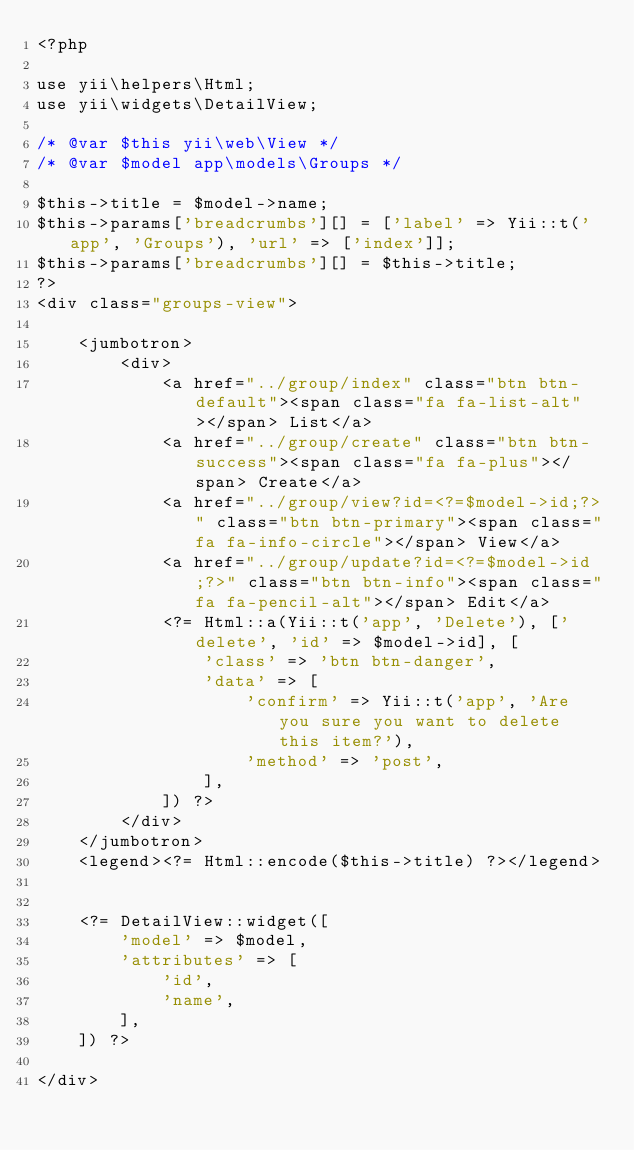<code> <loc_0><loc_0><loc_500><loc_500><_PHP_><?php

use yii\helpers\Html;
use yii\widgets\DetailView;

/* @var $this yii\web\View */
/* @var $model app\models\Groups */

$this->title = $model->name;
$this->params['breadcrumbs'][] = ['label' => Yii::t('app', 'Groups'), 'url' => ['index']];
$this->params['breadcrumbs'][] = $this->title;
?>
<div class="groups-view">

    <jumbotron>
        <div>
            <a href="../group/index" class="btn btn-default"><span class="fa fa-list-alt"></span> List</a>
            <a href="../group/create" class="btn btn-success"><span class="fa fa-plus"></span> Create</a>
            <a href="../group/view?id=<?=$model->id;?>" class="btn btn-primary"><span class="fa fa-info-circle"></span> View</a>
            <a href="../group/update?id=<?=$model->id;?>" class="btn btn-info"><span class="fa fa-pencil-alt"></span> Edit</a>
            <?= Html::a(Yii::t('app', 'Delete'), ['delete', 'id' => $model->id], [
                'class' => 'btn btn-danger',
                'data' => [
                    'confirm' => Yii::t('app', 'Are you sure you want to delete this item?'),
                    'method' => 'post',
                ],
            ]) ?>
        </div>
    </jumbotron>
    <legend><?= Html::encode($this->title) ?></legend>


    <?= DetailView::widget([
        'model' => $model,
        'attributes' => [
            'id',
            'name',
        ],
    ]) ?>

</div>
</code> 